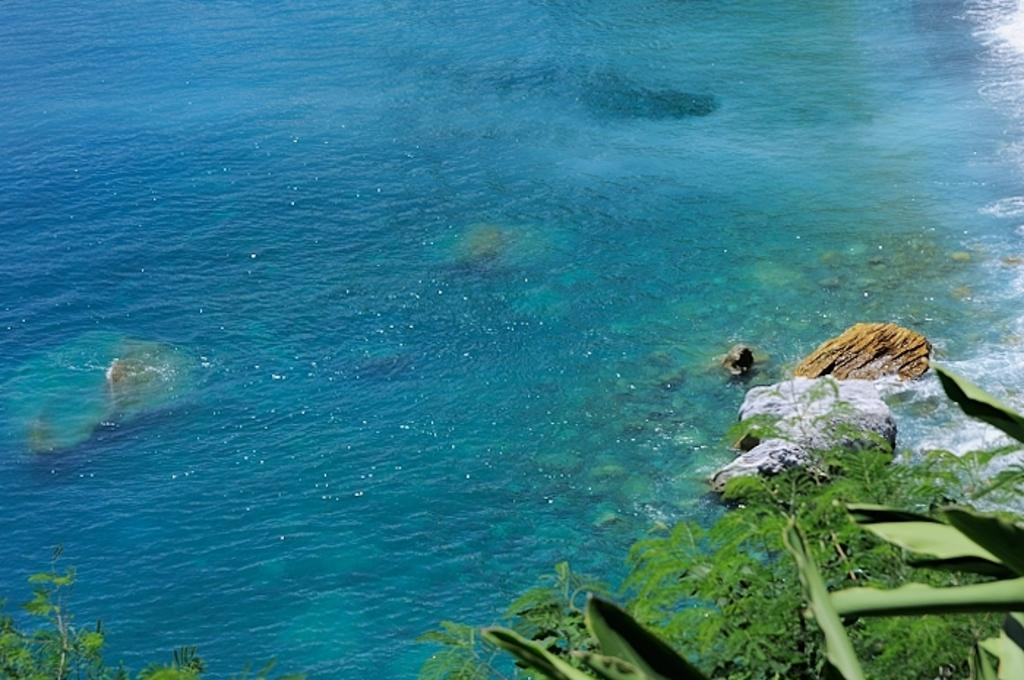What can be seen floating in the water in the image? There are rocks in the water in the image. What is located at the bottom of the image? Leaves are present at the bottom of the image. What type of scent can be detected from the image? There is no information about a scent in the image, so it cannot be determined. 